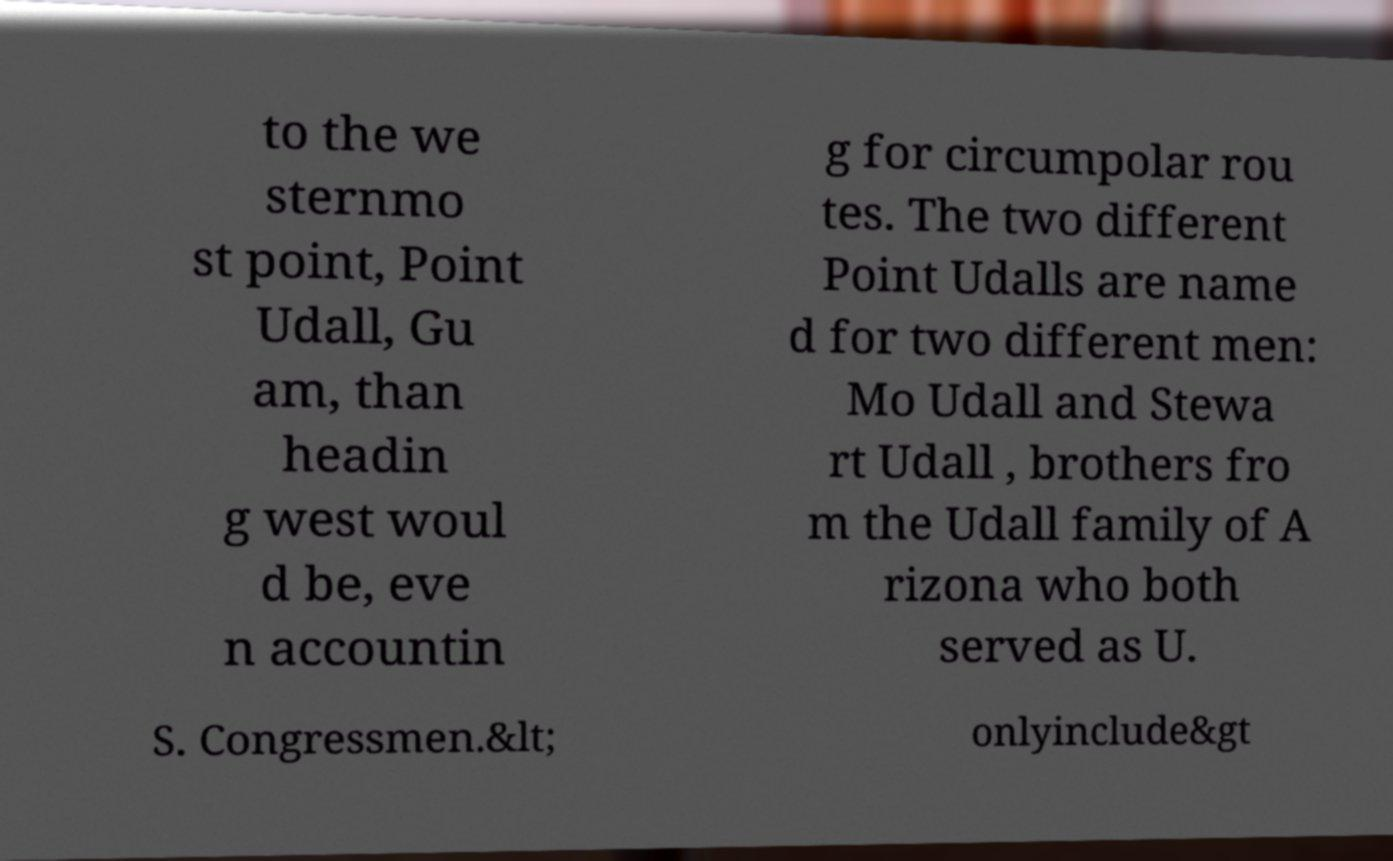Please read and relay the text visible in this image. What does it say? to the we sternmo st point, Point Udall, Gu am, than headin g west woul d be, eve n accountin g for circumpolar rou tes. The two different Point Udalls are name d for two different men: Mo Udall and Stewa rt Udall , brothers fro m the Udall family of A rizona who both served as U. S. Congressmen.&lt; onlyinclude&gt 